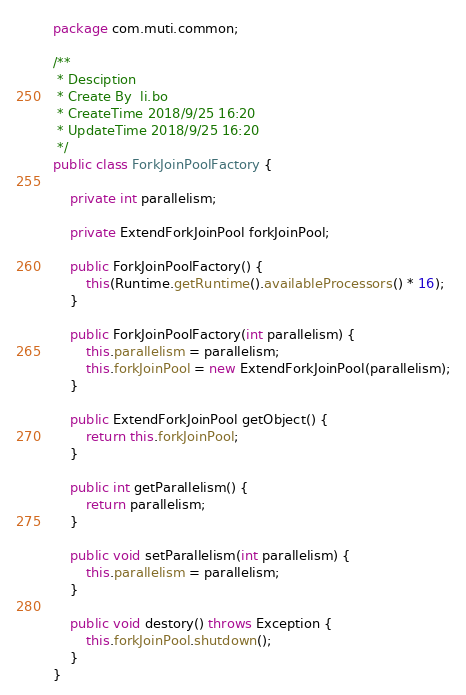Convert code to text. <code><loc_0><loc_0><loc_500><loc_500><_Java_>package com.muti.common;

/**
 * Desciption
 * Create By  li.bo
 * CreateTime 2018/9/25 16:20
 * UpdateTime 2018/9/25 16:20
 */
public class ForkJoinPoolFactory {

    private int parallelism;

    private ExtendForkJoinPool forkJoinPool;

    public ForkJoinPoolFactory() {
        this(Runtime.getRuntime().availableProcessors() * 16);
    }

    public ForkJoinPoolFactory(int parallelism) {
        this.parallelism = parallelism;
        this.forkJoinPool = new ExtendForkJoinPool(parallelism);
    }

    public ExtendForkJoinPool getObject() {
        return this.forkJoinPool;
    }

    public int getParallelism() {
        return parallelism;
    }

    public void setParallelism(int parallelism) {
        this.parallelism = parallelism;
    }

    public void destory() throws Exception {
        this.forkJoinPool.shutdown();
    }
}
</code> 